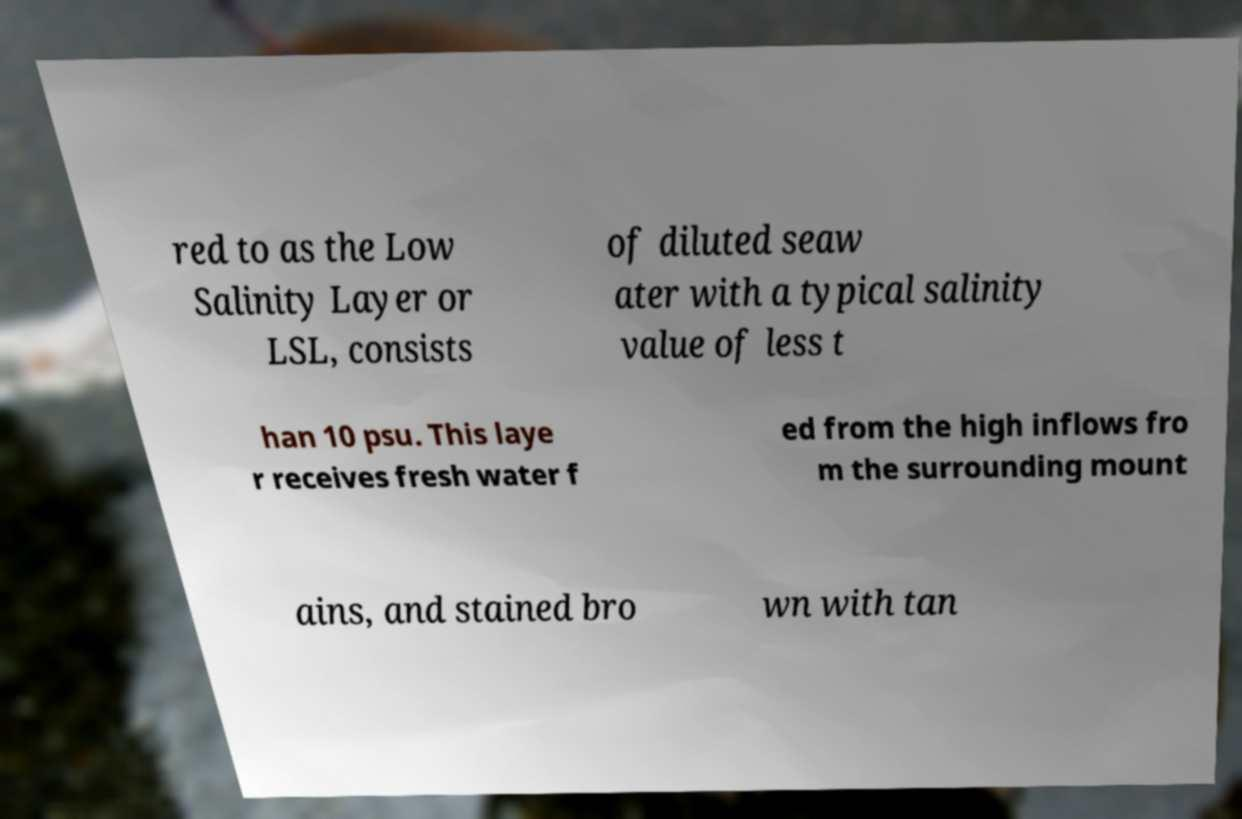Can you read and provide the text displayed in the image?This photo seems to have some interesting text. Can you extract and type it out for me? red to as the Low Salinity Layer or LSL, consists of diluted seaw ater with a typical salinity value of less t han 10 psu. This laye r receives fresh water f ed from the high inflows fro m the surrounding mount ains, and stained bro wn with tan 